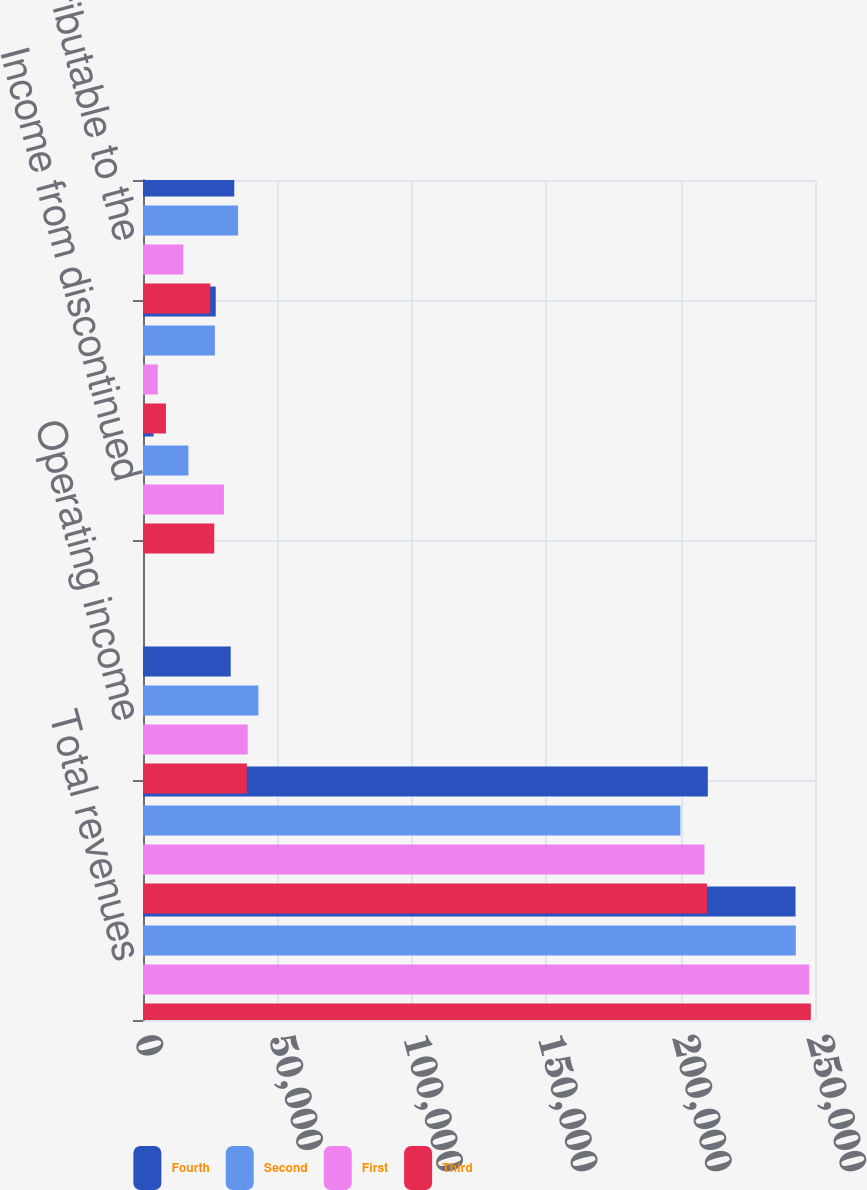Convert chart to OTSL. <chart><loc_0><loc_0><loc_500><loc_500><stacked_bar_chart><ecel><fcel>Total revenues<fcel>Total operating expenses<fcel>Operating income<fcel>Loss from continuing<fcel>Income from discontinued<fcel>Net (loss) income<fcel>Loss attributable to the<nl><fcel>Fourth<fcel>242761<fcel>210126<fcel>32635<fcel>0.32<fcel>3938<fcel>27065<fcel>33944<nl><fcel>Second<fcel>242868<fcel>199930<fcel>42938<fcel>0.37<fcel>16888<fcel>26747<fcel>35373<nl><fcel>First<fcel>247838<fcel>208884<fcel>38954<fcel>0.27<fcel>30106<fcel>5481<fcel>15012<nl><fcel>Third<fcel>248452<fcel>209822<fcel>38630<fcel>0.3<fcel>26507<fcel>8534<fcel>25036<nl></chart> 